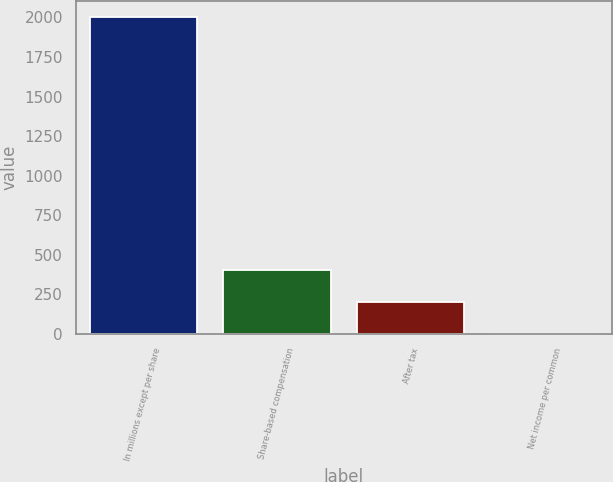Convert chart to OTSL. <chart><loc_0><loc_0><loc_500><loc_500><bar_chart><fcel>In millions except per share<fcel>Share-based compensation<fcel>After tax<fcel>Net income per common<nl><fcel>2006<fcel>401.25<fcel>200.66<fcel>0.07<nl></chart> 